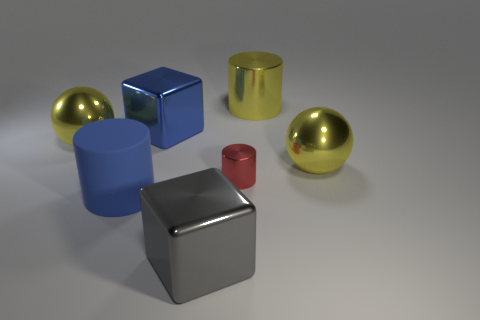What material is the large cube that is to the left of the block in front of the big cylinder in front of the yellow metallic cylinder?
Your response must be concise. Metal. There is a matte cylinder; is its color the same as the shiny cube behind the big blue matte thing?
Your answer should be very brief. Yes. How many things are cylinders on the right side of the blue matte cylinder or large yellow spheres right of the red metal object?
Offer a very short reply. 3. What shape is the large blue object that is behind the big yellow thing that is left of the gray block?
Offer a terse response. Cube. Is there a big blue cylinder made of the same material as the gray thing?
Keep it short and to the point. No. There is a big metal thing that is the same shape as the matte object; what is its color?
Your answer should be compact. Yellow. Is the number of metal things to the left of the blue metal thing less than the number of gray things right of the rubber thing?
Ensure brevity in your answer.  No. How many other objects are the same shape as the big blue matte object?
Your response must be concise. 2. Is the number of balls that are to the right of the tiny red thing less than the number of big blue blocks?
Keep it short and to the point. No. There is a yellow sphere that is to the left of the big gray cube; what material is it?
Give a very brief answer. Metal. 